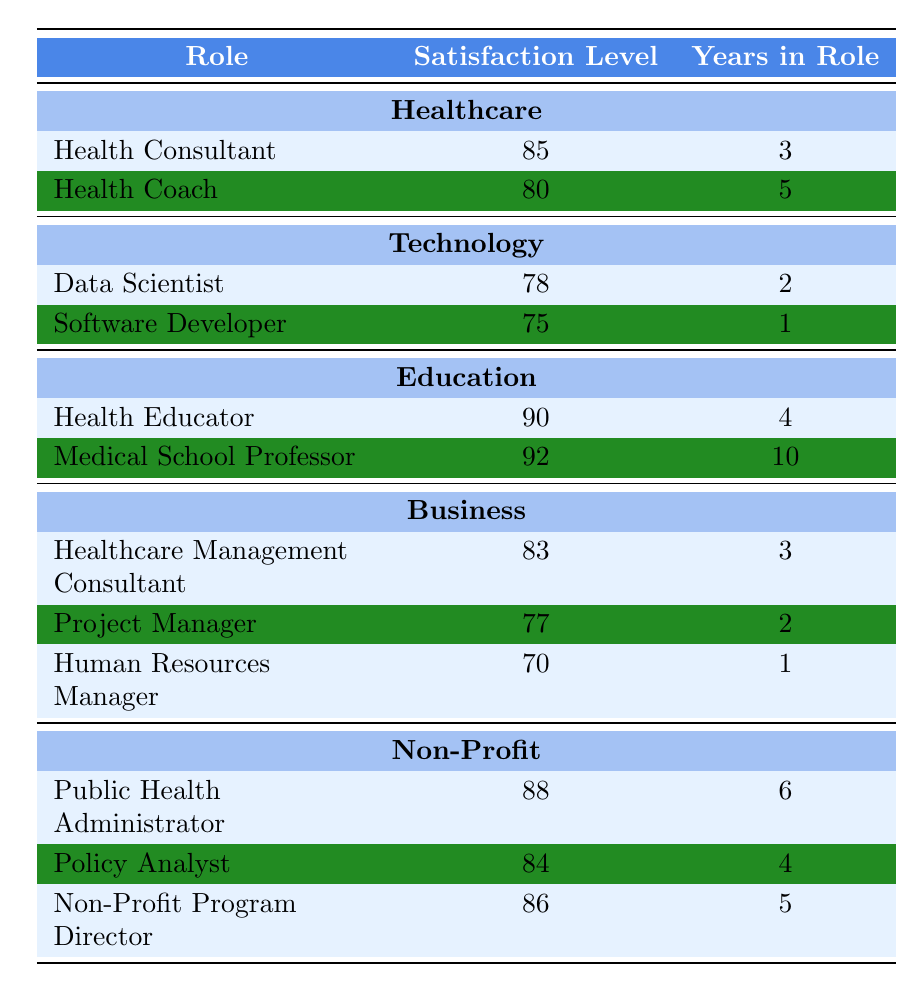What is the highest satisfaction level among the roles listed? The table shows that the Medical School Professor has the highest satisfaction level at 92.
Answer: 92 What role in the Education industry has the second-highest satisfaction level? The table indicates that the Health Educator has a satisfaction level of 90, which is the second-highest in the Education industry.
Answer: 90 Which role has the least amount of years in the role? The Software Developer in the Technology industry has the least amount of years in the role at just 1 year.
Answer: 1 Calculate the average satisfaction level for roles in the Non-Profit industry. The satisfaction levels for Non-Profit roles are 88, 84, and 86. The sum is 88 + 84 + 86 = 258. There are 3 roles, so the average is 258 / 3 = 86.
Answer: 86 Is the satisfaction level of a Data Scientist higher than that of a Human Resources Manager? The Data Scientist has a satisfaction level of 78, while the Human Resources Manager has a level of 70. Therefore, yes, the satisfaction level of a Data Scientist is higher.
Answer: Yes What is the difference in satisfaction levels between the Health Consultant and the Project Manager? The satisfaction level of the Health Consultant is 85, and the Project Manager is 77. The difference is 85 - 77 = 8.
Answer: 8 Which role has the longest duration in their role? The Medical School Professor has the longest duration in their role at 10 years.
Answer: 10 years Do roles in the Education industry tend to have higher satisfaction levels than those in the Business industry? The highest satisfaction level in Education is 92 (Medical School Professor), and the highest in Business is 83 (Healthcare Management Consultant). Since 92 is greater than 83, it appears that roles in the Education industry do tend to have higher satisfaction levels.
Answer: Yes What is the total years in role for all the roles listed in the Technology industry? The years in role for Technology are 2 (Data Scientist) + 1 (Software Developer) = 3.
Answer: 3 years Identify the role with the highest satisfaction within the Healthcare industry and how many years they have been in that role. The Health Educator has the highest satisfaction level of 90 with 4 years in their role.
Answer: 90, 4 years 